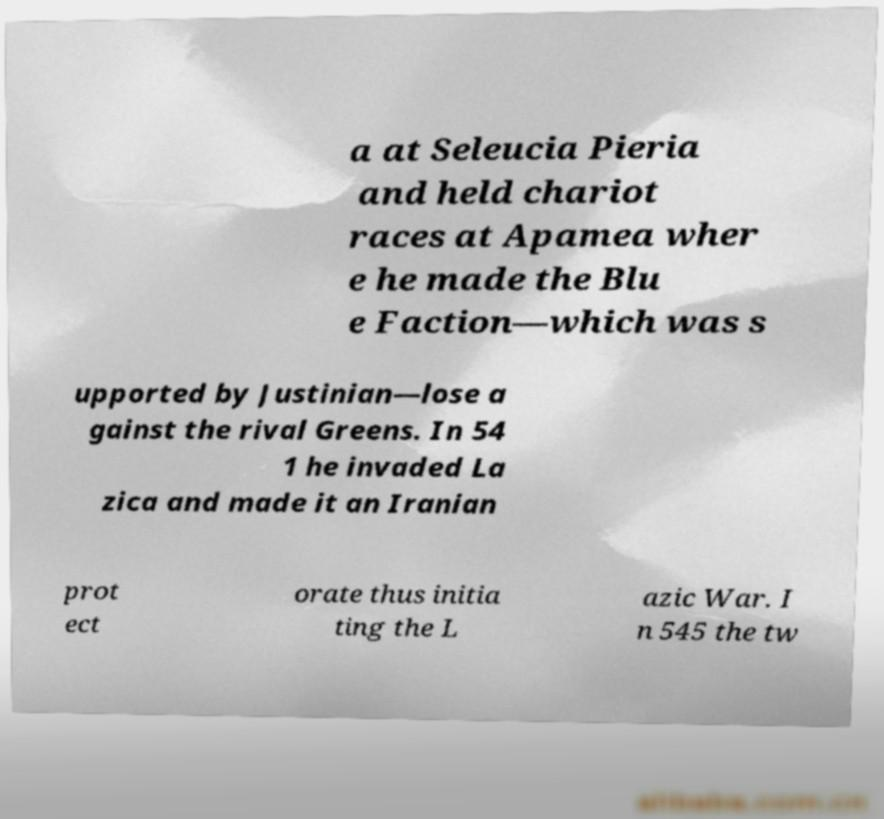Please read and relay the text visible in this image. What does it say? a at Seleucia Pieria and held chariot races at Apamea wher e he made the Blu e Faction—which was s upported by Justinian—lose a gainst the rival Greens. In 54 1 he invaded La zica and made it an Iranian prot ect orate thus initia ting the L azic War. I n 545 the tw 